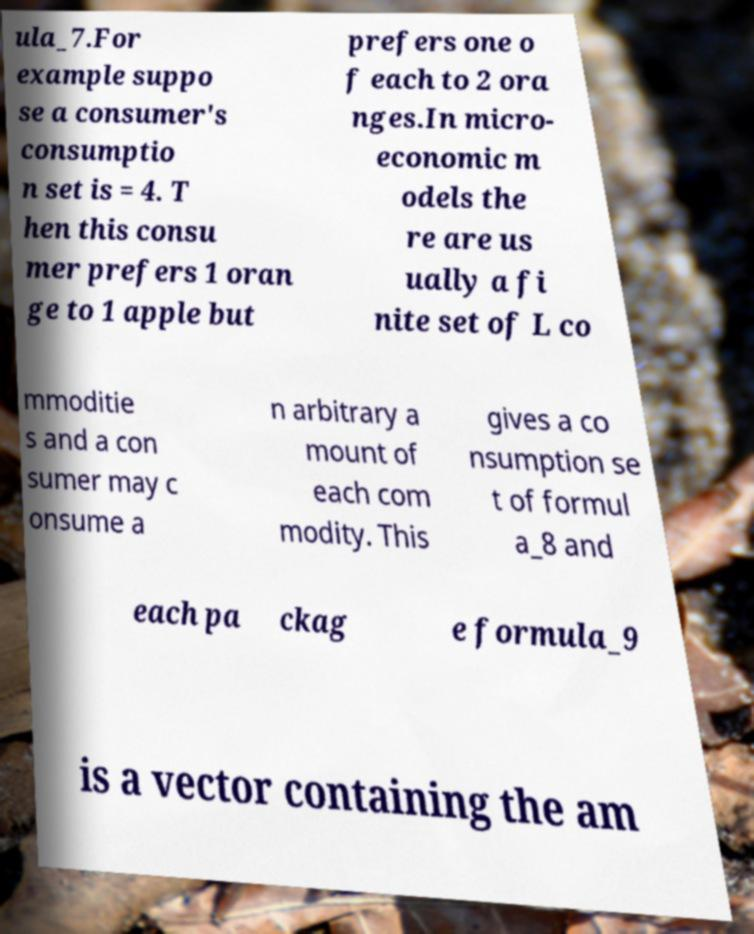There's text embedded in this image that I need extracted. Can you transcribe it verbatim? ula_7.For example suppo se a consumer's consumptio n set is = 4. T hen this consu mer prefers 1 oran ge to 1 apple but prefers one o f each to 2 ora nges.In micro- economic m odels the re are us ually a fi nite set of L co mmoditie s and a con sumer may c onsume a n arbitrary a mount of each com modity. This gives a co nsumption se t of formul a_8 and each pa ckag e formula_9 is a vector containing the am 